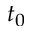Convert formula to latex. <formula><loc_0><loc_0><loc_500><loc_500>t _ { 0 }</formula> 